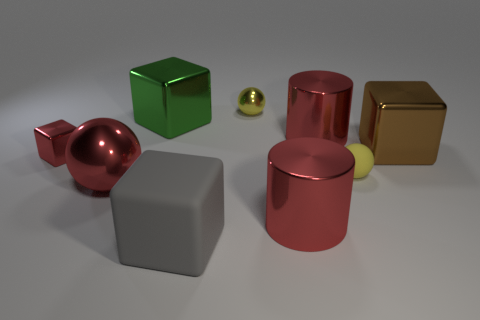Subtract all yellow spheres. How many were subtracted if there are1yellow spheres left? 1 Subtract all small balls. How many balls are left? 1 Add 1 tiny red shiny objects. How many objects exist? 10 Subtract all cylinders. How many objects are left? 7 Subtract all purple blocks. Subtract all yellow cylinders. How many blocks are left? 4 Subtract all purple balls. Subtract all large cubes. How many objects are left? 6 Add 6 large red metal cylinders. How many large red metal cylinders are left? 8 Add 2 gray blocks. How many gray blocks exist? 3 Subtract 1 yellow balls. How many objects are left? 8 